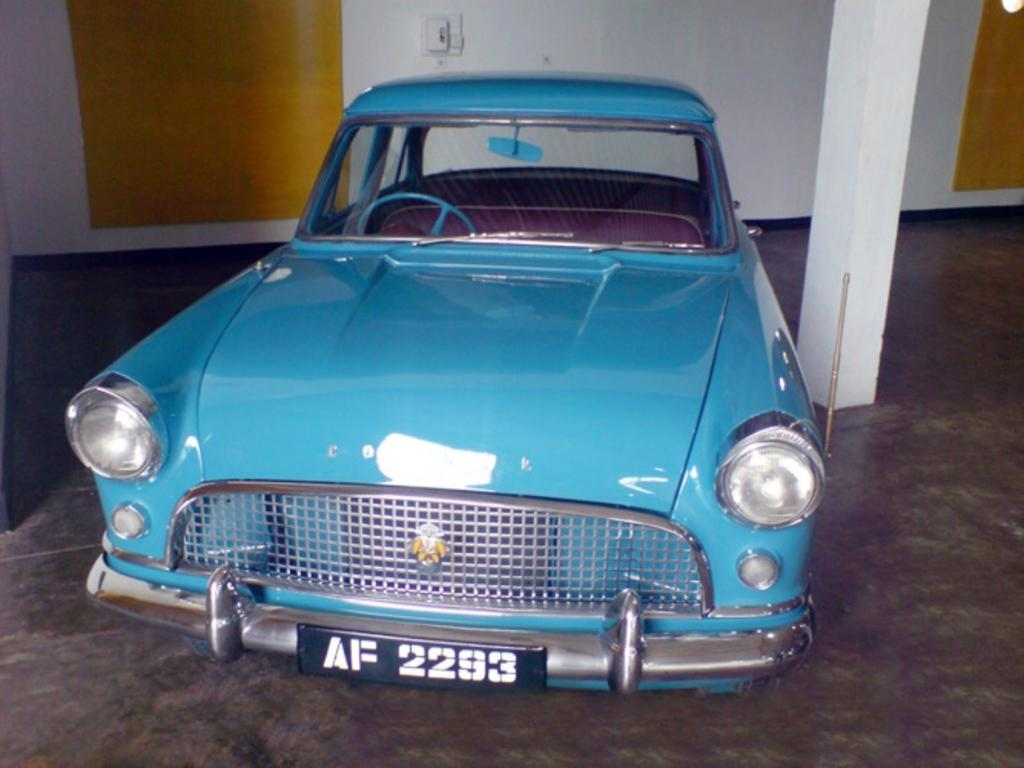What type of car can be seen in the image? There is a blue classic car in the image. Where is the car located in the image? The car is parked in a parking area. What can be seen in the background of the image? There is a white and yellow wall visible in the background of the image. How many tomatoes are hanging from the branch in the image? There is no branch or tomatoes present in the image. 